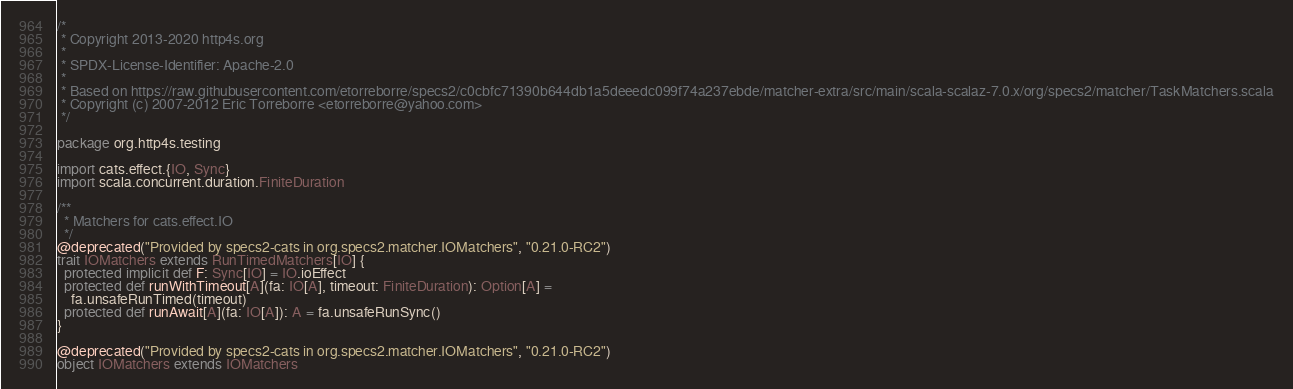Convert code to text. <code><loc_0><loc_0><loc_500><loc_500><_Scala_>/*
 * Copyright 2013-2020 http4s.org
 *
 * SPDX-License-Identifier: Apache-2.0
 *
 * Based on https://raw.githubusercontent.com/etorreborre/specs2/c0cbfc71390b644db1a5deeedc099f74a237ebde/matcher-extra/src/main/scala-scalaz-7.0.x/org/specs2/matcher/TaskMatchers.scala
 * Copyright (c) 2007-2012 Eric Torreborre <etorreborre@yahoo.com>
 */

package org.http4s.testing

import cats.effect.{IO, Sync}
import scala.concurrent.duration.FiniteDuration

/**
  * Matchers for cats.effect.IO
  */
@deprecated("Provided by specs2-cats in org.specs2.matcher.IOMatchers", "0.21.0-RC2")
trait IOMatchers extends RunTimedMatchers[IO] {
  protected implicit def F: Sync[IO] = IO.ioEffect
  protected def runWithTimeout[A](fa: IO[A], timeout: FiniteDuration): Option[A] =
    fa.unsafeRunTimed(timeout)
  protected def runAwait[A](fa: IO[A]): A = fa.unsafeRunSync()
}

@deprecated("Provided by specs2-cats in org.specs2.matcher.IOMatchers", "0.21.0-RC2")
object IOMatchers extends IOMatchers
</code> 